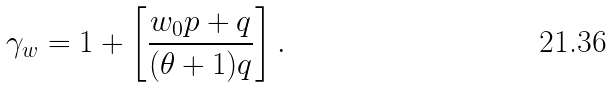Convert formula to latex. <formula><loc_0><loc_0><loc_500><loc_500>\gamma _ { w } = 1 + \left [ \frac { w _ { 0 } p + q } { ( \theta + 1 ) q } \right ] .</formula> 